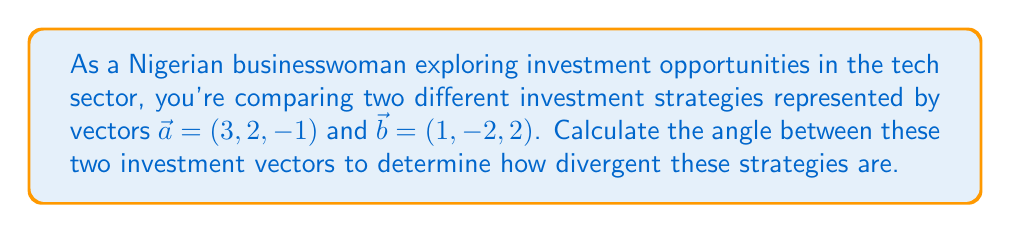Provide a solution to this math problem. To find the angle between two vectors, we'll use the dot product formula:

$$\cos \theta = \frac{\vec{a} \cdot \vec{b}}{|\vec{a}||\vec{b}|}$$

Step 1: Calculate the dot product $\vec{a} \cdot \vec{b}$
$$\vec{a} \cdot \vec{b} = (3)(1) + (2)(-2) + (-1)(2) = 3 - 4 - 2 = -3$$

Step 2: Calculate the magnitudes of $\vec{a}$ and $\vec{b}$
$$|\vec{a}| = \sqrt{3^2 + 2^2 + (-1)^2} = \sqrt{9 + 4 + 1} = \sqrt{14}$$
$$|\vec{b}| = \sqrt{1^2 + (-2)^2 + 2^2} = \sqrt{1 + 4 + 4} = 3$$

Step 3: Substitute into the formula
$$\cos \theta = \frac{-3}{\sqrt{14} \cdot 3}$$

Step 4: Simplify
$$\cos \theta = -\frac{1}{\sqrt{14}}$$

Step 5: Take the inverse cosine (arccos) of both sides
$$\theta = \arccos(-\frac{1}{\sqrt{14}})$$

Step 6: Calculate the result (approximately)
$$\theta \approx 1.8235 \text{ radians} \approx 104.48°$$
Answer: $104.48°$ 